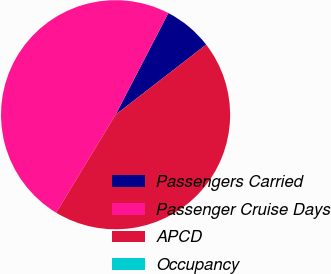Convert chart. <chart><loc_0><loc_0><loc_500><loc_500><pie_chart><fcel>Passengers Carried<fcel>Passenger Cruise Days<fcel>APCD<fcel>Occupancy<nl><fcel>6.9%<fcel>48.94%<fcel>44.16%<fcel>0.0%<nl></chart> 